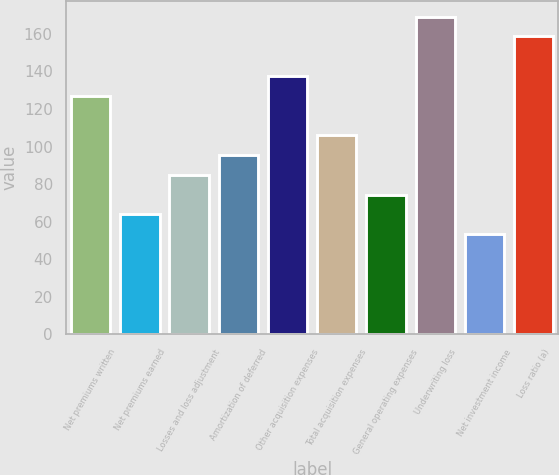Convert chart to OTSL. <chart><loc_0><loc_0><loc_500><loc_500><bar_chart><fcel>Net premiums written<fcel>Net premiums earned<fcel>Losses and loss adjustment<fcel>Amortization of deferred<fcel>Other acquisition expenses<fcel>Total acquisition expenses<fcel>General operating expenses<fcel>Underwriting loss<fcel>Net investment income<fcel>Loss ratio (a)<nl><fcel>127.06<fcel>63.88<fcel>84.94<fcel>95.47<fcel>137.59<fcel>106<fcel>74.41<fcel>169.18<fcel>53.35<fcel>158.65<nl></chart> 